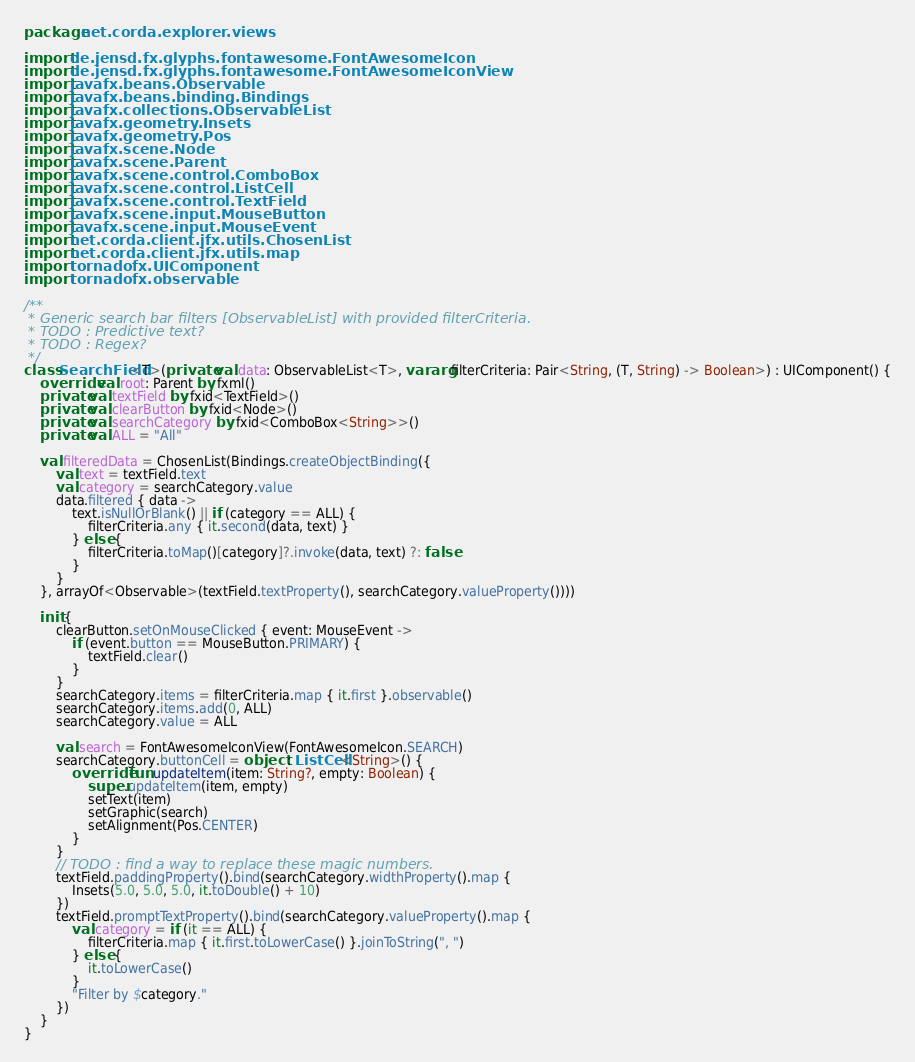Convert code to text. <code><loc_0><loc_0><loc_500><loc_500><_Kotlin_>package net.corda.explorer.views

import de.jensd.fx.glyphs.fontawesome.FontAwesomeIcon
import de.jensd.fx.glyphs.fontawesome.FontAwesomeIconView
import javafx.beans.Observable
import javafx.beans.binding.Bindings
import javafx.collections.ObservableList
import javafx.geometry.Insets
import javafx.geometry.Pos
import javafx.scene.Node
import javafx.scene.Parent
import javafx.scene.control.ComboBox
import javafx.scene.control.ListCell
import javafx.scene.control.TextField
import javafx.scene.input.MouseButton
import javafx.scene.input.MouseEvent
import net.corda.client.jfx.utils.ChosenList
import net.corda.client.jfx.utils.map
import tornadofx.UIComponent
import tornadofx.observable

/**
 * Generic search bar filters [ObservableList] with provided filterCriteria.
 * TODO : Predictive text?
 * TODO : Regex?
 */
class SearchField<T>(private val data: ObservableList<T>, vararg filterCriteria: Pair<String, (T, String) -> Boolean>) : UIComponent() {
    override val root: Parent by fxml()
    private val textField by fxid<TextField>()
    private val clearButton by fxid<Node>()
    private val searchCategory by fxid<ComboBox<String>>()
    private val ALL = "All"

    val filteredData = ChosenList(Bindings.createObjectBinding({
        val text = textField.text
        val category = searchCategory.value
        data.filtered { data ->
            text.isNullOrBlank() || if (category == ALL) {
                filterCriteria.any { it.second(data, text) }
            } else {
                filterCriteria.toMap()[category]?.invoke(data, text) ?: false
            }
        }
    }, arrayOf<Observable>(textField.textProperty(), searchCategory.valueProperty())))

    init {
        clearButton.setOnMouseClicked { event: MouseEvent ->
            if (event.button == MouseButton.PRIMARY) {
                textField.clear()
            }
        }
        searchCategory.items = filterCriteria.map { it.first }.observable()
        searchCategory.items.add(0, ALL)
        searchCategory.value = ALL

        val search = FontAwesomeIconView(FontAwesomeIcon.SEARCH)
        searchCategory.buttonCell = object : ListCell<String>() {
            override fun updateItem(item: String?, empty: Boolean) {
                super.updateItem(item, empty)
                setText(item)
                setGraphic(search)
                setAlignment(Pos.CENTER)
            }
        }
        // TODO : find a way to replace these magic numbers.
        textField.paddingProperty().bind(searchCategory.widthProperty().map {
            Insets(5.0, 5.0, 5.0, it.toDouble() + 10)
        })
        textField.promptTextProperty().bind(searchCategory.valueProperty().map {
            val category = if (it == ALL) {
                filterCriteria.map { it.first.toLowerCase() }.joinToString(", ")
            } else {
                it.toLowerCase()
            }
            "Filter by $category."
        })
    }
}</code> 